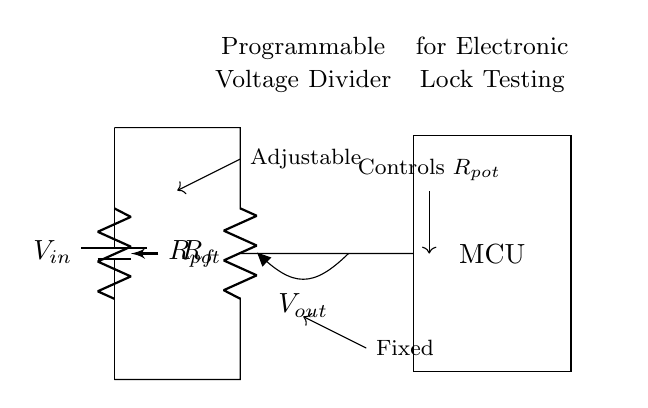What is the type of the adjustable resistor in this circuit? The adjustable resistor in the circuit is labeled as R_pot, indicating it is a potentiometer. A potentiometer is a type of variable resistor used to adjust voltage levels.
Answer: Potentiometer What does V_out represent in this diagram? V_out represents the output voltage from the voltage divider circuit. It is taken across the fixed resistor (R_f) and is dependent on the values of the resistors and the input voltage (V_in).
Answer: Output voltage What role does the microcontroller serve in this circuit? The microcontroller (labeled as MCU) receives the output voltage (V_out) to process the voltage signal for electronic lock testing, enabling control and programming of the locking mechanism based on the simulated voltage levels.
Answer: Control What are the resistor components present in the circuit? The circuit contains two types of resistors: a potentiometer labeled R_pot, which is adjustable, and a fixed resistor labeled R_f, which has a constant value. These components create the voltage divider configuration.
Answer: R_pot and R_f What voltage source is used in this circuit? The circuit uses a battery as the voltage source, indicated by the symbol for a battery (labeled as V_in) at the top of the circuit diagram. This voltage provides the necessary power for the voltage divider to operate.
Answer: Battery How does the adjustable resistor affect the output voltage? The adjustable resistor (R_pot) alters the division of the input voltage between R_pot and R_f. By changing R_pot's resistance, one can vary V_out, simulating different voltage scenarios required for testing the electronic lock.
Answer: Varies output voltage What is the primary purpose of this programmable voltage divider circuit? The primary purpose of this programmable voltage divider circuit is to simulate various power supply scenarios for electronic lock testing, allowing for the evaluation of how the lock performs under different voltage conditions.
Answer: Electronic lock testing 